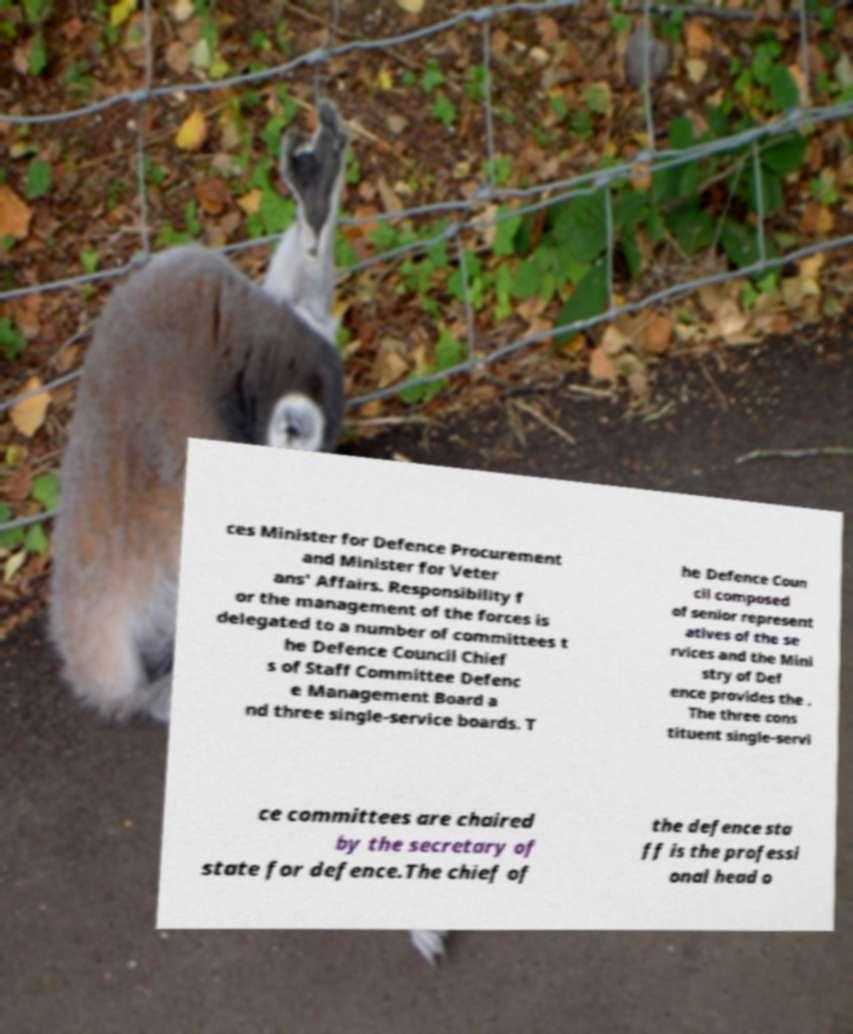Can you accurately transcribe the text from the provided image for me? ces Minister for Defence Procurement and Minister for Veter ans' Affairs. Responsibility f or the management of the forces is delegated to a number of committees t he Defence Council Chief s of Staff Committee Defenc e Management Board a nd three single-service boards. T he Defence Coun cil composed of senior represent atives of the se rvices and the Mini stry of Def ence provides the . The three cons tituent single-servi ce committees are chaired by the secretary of state for defence.The chief of the defence sta ff is the professi onal head o 